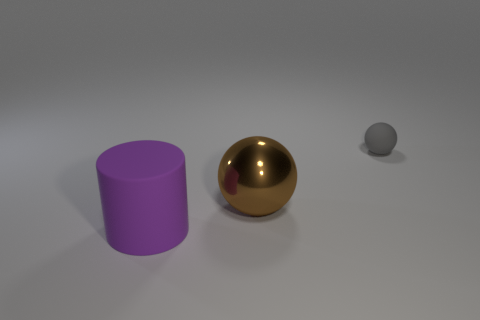Add 2 gray matte cylinders. How many objects exist? 5 Subtract 0 cyan cylinders. How many objects are left? 3 Subtract all spheres. How many objects are left? 1 Subtract all tiny matte things. Subtract all brown metallic cylinders. How many objects are left? 2 Add 1 gray things. How many gray things are left? 2 Add 2 small red shiny spheres. How many small red shiny spheres exist? 2 